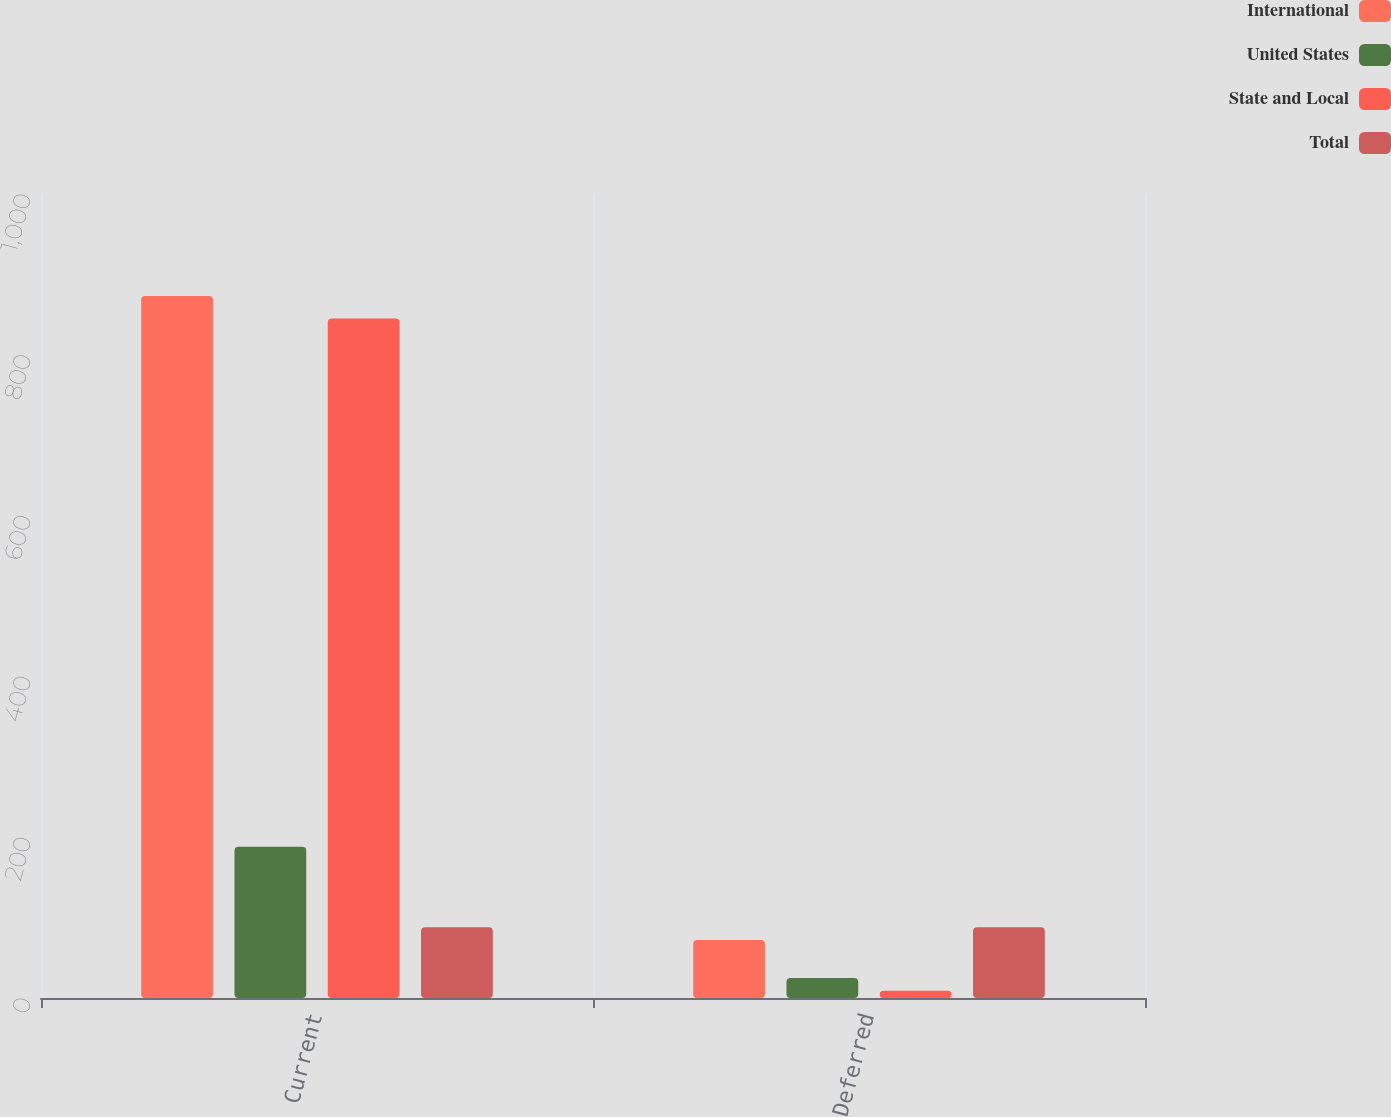Convert chart to OTSL. <chart><loc_0><loc_0><loc_500><loc_500><stacked_bar_chart><ecel><fcel>Current<fcel>Deferred<nl><fcel>International<fcel>873<fcel>72<nl><fcel>United States<fcel>188<fcel>25<nl><fcel>State and Local<fcel>845<fcel>9<nl><fcel>Total<fcel>88<fcel>88<nl></chart> 